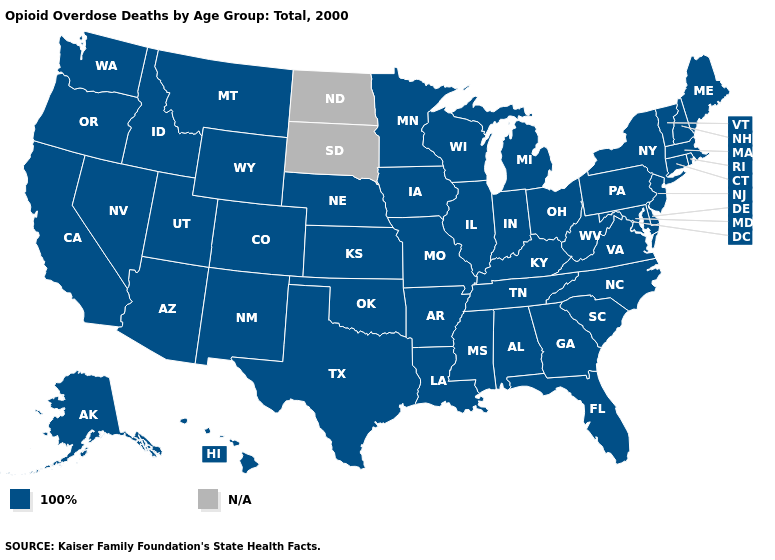What is the value of California?
Short answer required. 100%. Among the states that border Illinois , which have the highest value?
Keep it brief. Indiana, Iowa, Kentucky, Missouri, Wisconsin. Which states hav the highest value in the Northeast?
Be succinct. Connecticut, Maine, Massachusetts, New Hampshire, New Jersey, New York, Pennsylvania, Rhode Island, Vermont. What is the lowest value in the USA?
Be succinct. 100%. What is the highest value in the USA?
Give a very brief answer. 100%. Name the states that have a value in the range 100%?
Keep it brief. Alabama, Alaska, Arizona, Arkansas, California, Colorado, Connecticut, Delaware, Florida, Georgia, Hawaii, Idaho, Illinois, Indiana, Iowa, Kansas, Kentucky, Louisiana, Maine, Maryland, Massachusetts, Michigan, Minnesota, Mississippi, Missouri, Montana, Nebraska, Nevada, New Hampshire, New Jersey, New Mexico, New York, North Carolina, Ohio, Oklahoma, Oregon, Pennsylvania, Rhode Island, South Carolina, Tennessee, Texas, Utah, Vermont, Virginia, Washington, West Virginia, Wisconsin, Wyoming. How many symbols are there in the legend?
Concise answer only. 2. Name the states that have a value in the range 100%?
Answer briefly. Alabama, Alaska, Arizona, Arkansas, California, Colorado, Connecticut, Delaware, Florida, Georgia, Hawaii, Idaho, Illinois, Indiana, Iowa, Kansas, Kentucky, Louisiana, Maine, Maryland, Massachusetts, Michigan, Minnesota, Mississippi, Missouri, Montana, Nebraska, Nevada, New Hampshire, New Jersey, New Mexico, New York, North Carolina, Ohio, Oklahoma, Oregon, Pennsylvania, Rhode Island, South Carolina, Tennessee, Texas, Utah, Vermont, Virginia, Washington, West Virginia, Wisconsin, Wyoming. What is the highest value in the USA?
Quick response, please. 100%. What is the value of California?
Answer briefly. 100%. Name the states that have a value in the range 100%?
Concise answer only. Alabama, Alaska, Arizona, Arkansas, California, Colorado, Connecticut, Delaware, Florida, Georgia, Hawaii, Idaho, Illinois, Indiana, Iowa, Kansas, Kentucky, Louisiana, Maine, Maryland, Massachusetts, Michigan, Minnesota, Mississippi, Missouri, Montana, Nebraska, Nevada, New Hampshire, New Jersey, New Mexico, New York, North Carolina, Ohio, Oklahoma, Oregon, Pennsylvania, Rhode Island, South Carolina, Tennessee, Texas, Utah, Vermont, Virginia, Washington, West Virginia, Wisconsin, Wyoming. What is the value of California?
Keep it brief. 100%. 